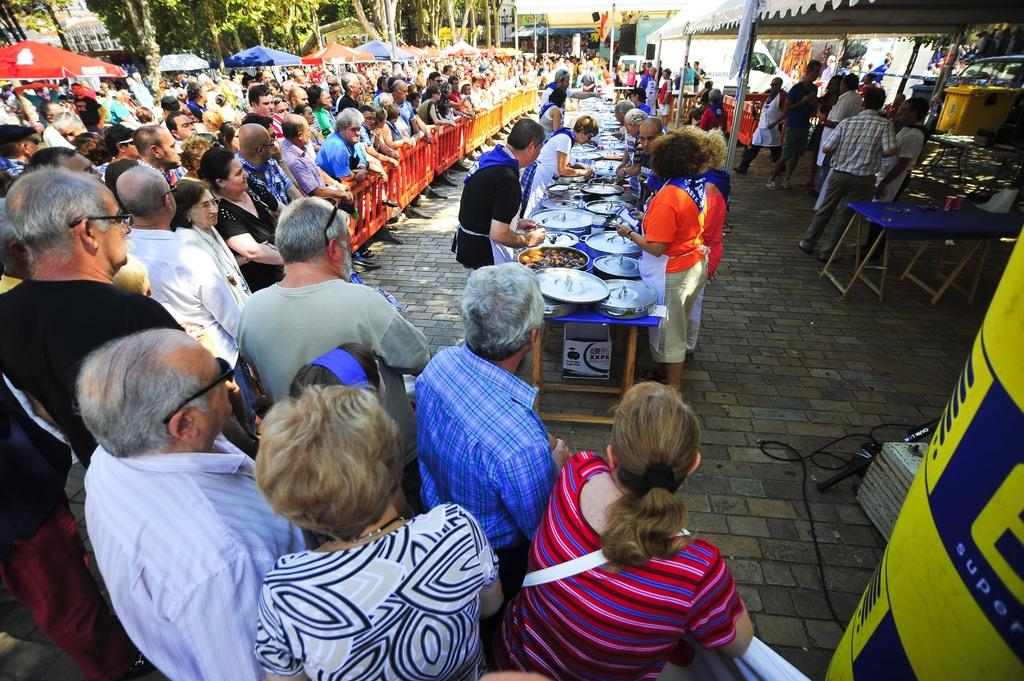What is the main activity of the people in the image? The people in the image are standing in groups. Can you describe the seating arrangement in the image? There are groups of people at a table in the image. Are there any people standing behind others in the image? Yes, there are groups of people standing behind others in the image. What type of riddle is the queen solving at the table in the image? There is no queen or riddle present in the image; it only shows groups of people standing and sitting. What flavor of soda is being served at the table in the image? There is no mention of soda or any beverages in the image; it only shows groups of people standing and sitting. 